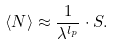Convert formula to latex. <formula><loc_0><loc_0><loc_500><loc_500>\langle N \rangle \approx \frac { 1 } { \lambda ^ { l _ { p } } } \cdot S .</formula> 